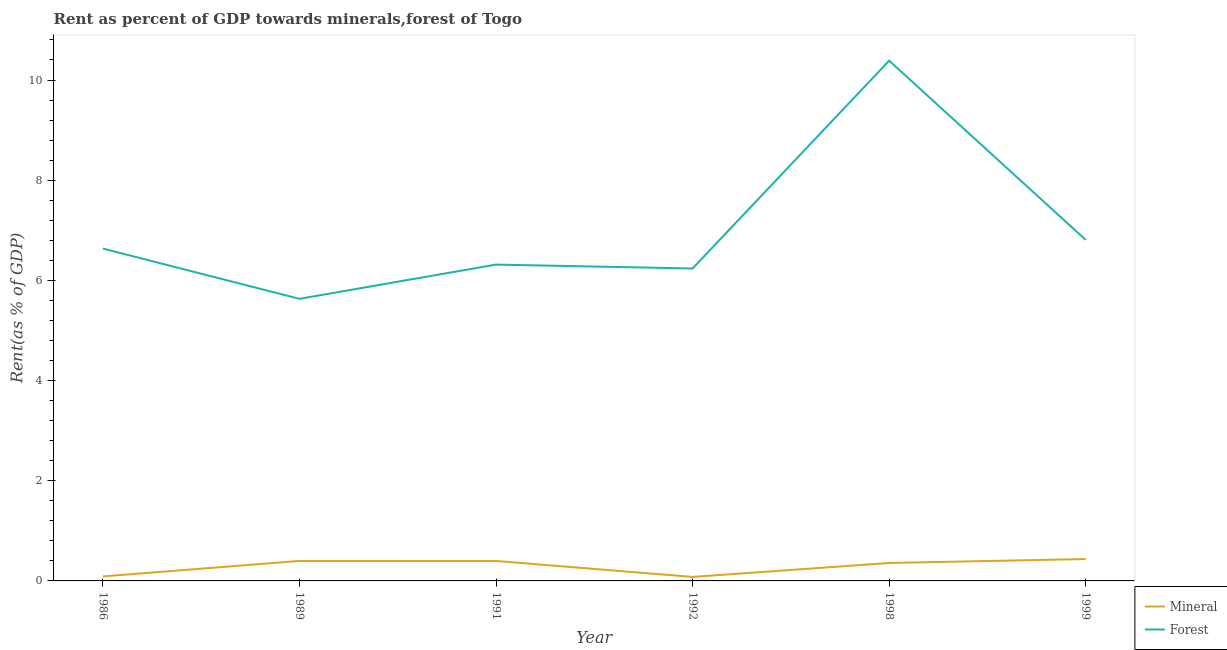How many different coloured lines are there?
Offer a terse response. 2. Does the line corresponding to mineral rent intersect with the line corresponding to forest rent?
Ensure brevity in your answer.  No. What is the mineral rent in 1999?
Offer a very short reply. 0.44. Across all years, what is the maximum forest rent?
Your response must be concise. 10.39. Across all years, what is the minimum mineral rent?
Keep it short and to the point. 0.08. In which year was the forest rent maximum?
Make the answer very short. 1998. In which year was the forest rent minimum?
Offer a very short reply. 1989. What is the total mineral rent in the graph?
Offer a very short reply. 1.76. What is the difference between the forest rent in 1986 and that in 1989?
Your answer should be compact. 1. What is the difference between the mineral rent in 1992 and the forest rent in 1986?
Offer a very short reply. -6.56. What is the average mineral rent per year?
Your response must be concise. 0.29. In the year 1999, what is the difference between the mineral rent and forest rent?
Offer a terse response. -6.37. In how many years, is the mineral rent greater than 0.4 %?
Your response must be concise. 1. What is the ratio of the forest rent in 1989 to that in 1999?
Offer a terse response. 0.83. Is the forest rent in 1989 less than that in 1992?
Provide a succinct answer. Yes. What is the difference between the highest and the second highest mineral rent?
Provide a short and direct response. 0.04. What is the difference between the highest and the lowest forest rent?
Your response must be concise. 4.75. In how many years, is the forest rent greater than the average forest rent taken over all years?
Provide a succinct answer. 1. Is the sum of the forest rent in 1991 and 1992 greater than the maximum mineral rent across all years?
Ensure brevity in your answer.  Yes. Is the mineral rent strictly less than the forest rent over the years?
Your answer should be compact. Yes. How many lines are there?
Your answer should be very brief. 2. What is the difference between two consecutive major ticks on the Y-axis?
Give a very brief answer. 2. Are the values on the major ticks of Y-axis written in scientific E-notation?
Give a very brief answer. No. Does the graph contain any zero values?
Provide a short and direct response. No. Does the graph contain grids?
Make the answer very short. No. How are the legend labels stacked?
Give a very brief answer. Vertical. What is the title of the graph?
Give a very brief answer. Rent as percent of GDP towards minerals,forest of Togo. What is the label or title of the Y-axis?
Offer a terse response. Rent(as % of GDP). What is the Rent(as % of GDP) in Mineral in 1986?
Provide a short and direct response. 0.09. What is the Rent(as % of GDP) of Forest in 1986?
Provide a short and direct response. 6.64. What is the Rent(as % of GDP) of Mineral in 1989?
Offer a terse response. 0.4. What is the Rent(as % of GDP) of Forest in 1989?
Your answer should be very brief. 5.63. What is the Rent(as % of GDP) in Mineral in 1991?
Your answer should be very brief. 0.4. What is the Rent(as % of GDP) in Forest in 1991?
Ensure brevity in your answer.  6.32. What is the Rent(as % of GDP) in Mineral in 1992?
Provide a succinct answer. 0.08. What is the Rent(as % of GDP) in Forest in 1992?
Give a very brief answer. 6.24. What is the Rent(as % of GDP) of Mineral in 1998?
Offer a very short reply. 0.36. What is the Rent(as % of GDP) of Forest in 1998?
Ensure brevity in your answer.  10.39. What is the Rent(as % of GDP) in Mineral in 1999?
Give a very brief answer. 0.44. What is the Rent(as % of GDP) of Forest in 1999?
Your answer should be compact. 6.81. Across all years, what is the maximum Rent(as % of GDP) of Mineral?
Give a very brief answer. 0.44. Across all years, what is the maximum Rent(as % of GDP) of Forest?
Make the answer very short. 10.39. Across all years, what is the minimum Rent(as % of GDP) of Mineral?
Your answer should be very brief. 0.08. Across all years, what is the minimum Rent(as % of GDP) of Forest?
Offer a very short reply. 5.63. What is the total Rent(as % of GDP) of Mineral in the graph?
Offer a very short reply. 1.76. What is the total Rent(as % of GDP) of Forest in the graph?
Keep it short and to the point. 42.01. What is the difference between the Rent(as % of GDP) in Mineral in 1986 and that in 1989?
Provide a short and direct response. -0.31. What is the difference between the Rent(as % of GDP) in Mineral in 1986 and that in 1991?
Offer a terse response. -0.31. What is the difference between the Rent(as % of GDP) in Forest in 1986 and that in 1991?
Provide a short and direct response. 0.32. What is the difference between the Rent(as % of GDP) in Mineral in 1986 and that in 1992?
Provide a short and direct response. 0.01. What is the difference between the Rent(as % of GDP) of Forest in 1986 and that in 1992?
Offer a very short reply. 0.4. What is the difference between the Rent(as % of GDP) of Mineral in 1986 and that in 1998?
Your answer should be compact. -0.27. What is the difference between the Rent(as % of GDP) in Forest in 1986 and that in 1998?
Your answer should be compact. -3.75. What is the difference between the Rent(as % of GDP) in Mineral in 1986 and that in 1999?
Provide a short and direct response. -0.35. What is the difference between the Rent(as % of GDP) in Forest in 1986 and that in 1999?
Your response must be concise. -0.17. What is the difference between the Rent(as % of GDP) in Mineral in 1989 and that in 1991?
Provide a succinct answer. 0. What is the difference between the Rent(as % of GDP) in Forest in 1989 and that in 1991?
Make the answer very short. -0.68. What is the difference between the Rent(as % of GDP) of Mineral in 1989 and that in 1992?
Make the answer very short. 0.32. What is the difference between the Rent(as % of GDP) in Forest in 1989 and that in 1992?
Make the answer very short. -0.61. What is the difference between the Rent(as % of GDP) of Mineral in 1989 and that in 1998?
Provide a succinct answer. 0.04. What is the difference between the Rent(as % of GDP) in Forest in 1989 and that in 1998?
Ensure brevity in your answer.  -4.75. What is the difference between the Rent(as % of GDP) of Mineral in 1989 and that in 1999?
Make the answer very short. -0.04. What is the difference between the Rent(as % of GDP) in Forest in 1989 and that in 1999?
Your answer should be compact. -1.18. What is the difference between the Rent(as % of GDP) in Mineral in 1991 and that in 1992?
Keep it short and to the point. 0.32. What is the difference between the Rent(as % of GDP) of Forest in 1991 and that in 1992?
Your answer should be compact. 0.08. What is the difference between the Rent(as % of GDP) of Mineral in 1991 and that in 1998?
Your answer should be very brief. 0.04. What is the difference between the Rent(as % of GDP) of Forest in 1991 and that in 1998?
Offer a very short reply. -4.07. What is the difference between the Rent(as % of GDP) of Mineral in 1991 and that in 1999?
Provide a succinct answer. -0.04. What is the difference between the Rent(as % of GDP) in Forest in 1991 and that in 1999?
Your answer should be compact. -0.49. What is the difference between the Rent(as % of GDP) of Mineral in 1992 and that in 1998?
Provide a succinct answer. -0.28. What is the difference between the Rent(as % of GDP) in Forest in 1992 and that in 1998?
Your response must be concise. -4.15. What is the difference between the Rent(as % of GDP) in Mineral in 1992 and that in 1999?
Your answer should be compact. -0.36. What is the difference between the Rent(as % of GDP) of Forest in 1992 and that in 1999?
Ensure brevity in your answer.  -0.57. What is the difference between the Rent(as % of GDP) in Mineral in 1998 and that in 1999?
Your response must be concise. -0.08. What is the difference between the Rent(as % of GDP) of Forest in 1998 and that in 1999?
Offer a very short reply. 3.58. What is the difference between the Rent(as % of GDP) in Mineral in 1986 and the Rent(as % of GDP) in Forest in 1989?
Provide a short and direct response. -5.54. What is the difference between the Rent(as % of GDP) in Mineral in 1986 and the Rent(as % of GDP) in Forest in 1991?
Keep it short and to the point. -6.22. What is the difference between the Rent(as % of GDP) of Mineral in 1986 and the Rent(as % of GDP) of Forest in 1992?
Provide a short and direct response. -6.15. What is the difference between the Rent(as % of GDP) of Mineral in 1986 and the Rent(as % of GDP) of Forest in 1998?
Offer a very short reply. -10.3. What is the difference between the Rent(as % of GDP) of Mineral in 1986 and the Rent(as % of GDP) of Forest in 1999?
Offer a very short reply. -6.72. What is the difference between the Rent(as % of GDP) in Mineral in 1989 and the Rent(as % of GDP) in Forest in 1991?
Ensure brevity in your answer.  -5.92. What is the difference between the Rent(as % of GDP) in Mineral in 1989 and the Rent(as % of GDP) in Forest in 1992?
Make the answer very short. -5.84. What is the difference between the Rent(as % of GDP) in Mineral in 1989 and the Rent(as % of GDP) in Forest in 1998?
Give a very brief answer. -9.99. What is the difference between the Rent(as % of GDP) in Mineral in 1989 and the Rent(as % of GDP) in Forest in 1999?
Give a very brief answer. -6.41. What is the difference between the Rent(as % of GDP) of Mineral in 1991 and the Rent(as % of GDP) of Forest in 1992?
Your response must be concise. -5.84. What is the difference between the Rent(as % of GDP) of Mineral in 1991 and the Rent(as % of GDP) of Forest in 1998?
Your response must be concise. -9.99. What is the difference between the Rent(as % of GDP) in Mineral in 1991 and the Rent(as % of GDP) in Forest in 1999?
Provide a short and direct response. -6.41. What is the difference between the Rent(as % of GDP) in Mineral in 1992 and the Rent(as % of GDP) in Forest in 1998?
Provide a succinct answer. -10.31. What is the difference between the Rent(as % of GDP) in Mineral in 1992 and the Rent(as % of GDP) in Forest in 1999?
Your answer should be very brief. -6.73. What is the difference between the Rent(as % of GDP) in Mineral in 1998 and the Rent(as % of GDP) in Forest in 1999?
Make the answer very short. -6.45. What is the average Rent(as % of GDP) of Mineral per year?
Give a very brief answer. 0.29. What is the average Rent(as % of GDP) in Forest per year?
Your response must be concise. 7. In the year 1986, what is the difference between the Rent(as % of GDP) of Mineral and Rent(as % of GDP) of Forest?
Offer a terse response. -6.55. In the year 1989, what is the difference between the Rent(as % of GDP) in Mineral and Rent(as % of GDP) in Forest?
Offer a very short reply. -5.23. In the year 1991, what is the difference between the Rent(as % of GDP) of Mineral and Rent(as % of GDP) of Forest?
Offer a very short reply. -5.92. In the year 1992, what is the difference between the Rent(as % of GDP) of Mineral and Rent(as % of GDP) of Forest?
Provide a short and direct response. -6.16. In the year 1998, what is the difference between the Rent(as % of GDP) of Mineral and Rent(as % of GDP) of Forest?
Ensure brevity in your answer.  -10.03. In the year 1999, what is the difference between the Rent(as % of GDP) of Mineral and Rent(as % of GDP) of Forest?
Provide a short and direct response. -6.37. What is the ratio of the Rent(as % of GDP) of Mineral in 1986 to that in 1989?
Offer a terse response. 0.23. What is the ratio of the Rent(as % of GDP) in Forest in 1986 to that in 1989?
Offer a terse response. 1.18. What is the ratio of the Rent(as % of GDP) in Mineral in 1986 to that in 1991?
Provide a succinct answer. 0.23. What is the ratio of the Rent(as % of GDP) in Forest in 1986 to that in 1991?
Give a very brief answer. 1.05. What is the ratio of the Rent(as % of GDP) in Mineral in 1986 to that in 1992?
Give a very brief answer. 1.13. What is the ratio of the Rent(as % of GDP) of Forest in 1986 to that in 1992?
Provide a succinct answer. 1.06. What is the ratio of the Rent(as % of GDP) in Mineral in 1986 to that in 1998?
Your answer should be compact. 0.25. What is the ratio of the Rent(as % of GDP) in Forest in 1986 to that in 1998?
Offer a terse response. 0.64. What is the ratio of the Rent(as % of GDP) in Mineral in 1986 to that in 1999?
Make the answer very short. 0.21. What is the ratio of the Rent(as % of GDP) in Forest in 1986 to that in 1999?
Provide a succinct answer. 0.97. What is the ratio of the Rent(as % of GDP) in Mineral in 1989 to that in 1991?
Offer a terse response. 1. What is the ratio of the Rent(as % of GDP) of Forest in 1989 to that in 1991?
Your answer should be compact. 0.89. What is the ratio of the Rent(as % of GDP) in Mineral in 1989 to that in 1992?
Offer a very short reply. 5. What is the ratio of the Rent(as % of GDP) of Forest in 1989 to that in 1992?
Offer a terse response. 0.9. What is the ratio of the Rent(as % of GDP) of Mineral in 1989 to that in 1998?
Offer a very short reply. 1.11. What is the ratio of the Rent(as % of GDP) in Forest in 1989 to that in 1998?
Make the answer very short. 0.54. What is the ratio of the Rent(as % of GDP) in Mineral in 1989 to that in 1999?
Your response must be concise. 0.91. What is the ratio of the Rent(as % of GDP) of Forest in 1989 to that in 1999?
Your response must be concise. 0.83. What is the ratio of the Rent(as % of GDP) of Mineral in 1991 to that in 1992?
Offer a very short reply. 4.99. What is the ratio of the Rent(as % of GDP) in Forest in 1991 to that in 1992?
Offer a very short reply. 1.01. What is the ratio of the Rent(as % of GDP) of Mineral in 1991 to that in 1998?
Ensure brevity in your answer.  1.11. What is the ratio of the Rent(as % of GDP) in Forest in 1991 to that in 1998?
Ensure brevity in your answer.  0.61. What is the ratio of the Rent(as % of GDP) of Mineral in 1991 to that in 1999?
Provide a succinct answer. 0.91. What is the ratio of the Rent(as % of GDP) in Forest in 1991 to that in 1999?
Offer a very short reply. 0.93. What is the ratio of the Rent(as % of GDP) of Mineral in 1992 to that in 1998?
Keep it short and to the point. 0.22. What is the ratio of the Rent(as % of GDP) of Forest in 1992 to that in 1998?
Your response must be concise. 0.6. What is the ratio of the Rent(as % of GDP) of Mineral in 1992 to that in 1999?
Your response must be concise. 0.18. What is the ratio of the Rent(as % of GDP) in Forest in 1992 to that in 1999?
Your answer should be very brief. 0.92. What is the ratio of the Rent(as % of GDP) in Mineral in 1998 to that in 1999?
Provide a short and direct response. 0.82. What is the ratio of the Rent(as % of GDP) in Forest in 1998 to that in 1999?
Your answer should be compact. 1.53. What is the difference between the highest and the second highest Rent(as % of GDP) of Mineral?
Your answer should be compact. 0.04. What is the difference between the highest and the second highest Rent(as % of GDP) of Forest?
Your answer should be compact. 3.58. What is the difference between the highest and the lowest Rent(as % of GDP) of Mineral?
Give a very brief answer. 0.36. What is the difference between the highest and the lowest Rent(as % of GDP) in Forest?
Ensure brevity in your answer.  4.75. 